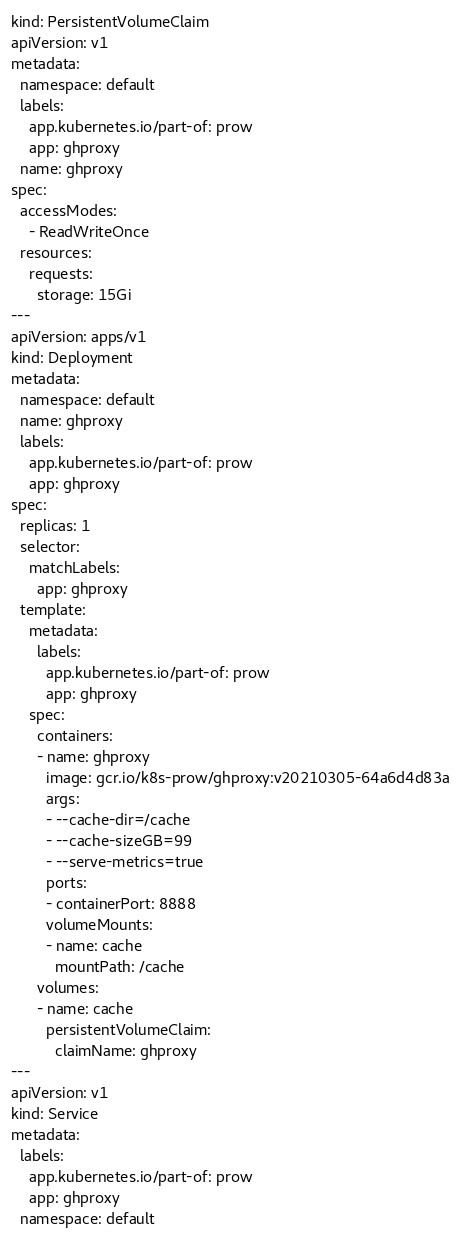<code> <loc_0><loc_0><loc_500><loc_500><_YAML_>kind: PersistentVolumeClaim
apiVersion: v1
metadata:
  namespace: default
  labels:
    app.kubernetes.io/part-of: prow
    app: ghproxy
  name: ghproxy
spec:
  accessModes:
    - ReadWriteOnce
  resources:
    requests:
      storage: 15Gi
---
apiVersion: apps/v1
kind: Deployment
metadata:
  namespace: default
  name: ghproxy
  labels:
    app.kubernetes.io/part-of: prow
    app: ghproxy
spec:
  replicas: 1
  selector:
    matchLabels:
      app: ghproxy
  template:
    metadata:
      labels:
        app.kubernetes.io/part-of: prow
        app: ghproxy
    spec:
      containers:
      - name: ghproxy
        image: gcr.io/k8s-prow/ghproxy:v20210305-64a6d4d83a
        args:
        - --cache-dir=/cache
        - --cache-sizeGB=99
        - --serve-metrics=true
        ports:
        - containerPort: 8888
        volumeMounts:
        - name: cache
          mountPath: /cache
      volumes:
      - name: cache
        persistentVolumeClaim:
          claimName: ghproxy
---
apiVersion: v1
kind: Service
metadata:
  labels:
    app.kubernetes.io/part-of: prow
    app: ghproxy
  namespace: default</code> 